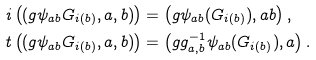<formula> <loc_0><loc_0><loc_500><loc_500>i \left ( ( g \psi _ { a b } G _ { i ( b ) } , a , b ) \right ) & = \left ( g \psi _ { a b } ( G _ { i ( b ) } ) , a b \right ) , \\ t \left ( ( g \psi _ { a b } G _ { i ( b ) } , a , b ) \right ) & = \left ( g g ^ { - 1 } _ { a , b } \psi _ { a b } ( G _ { i ( b ) } ) , a \right ) .</formula> 